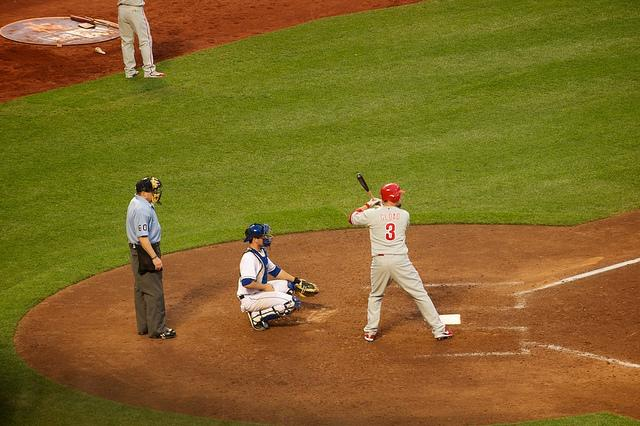Why is the batter wearing gloves?

Choices:
A) warmth
B) germs
C) fashion
D) grip grip 